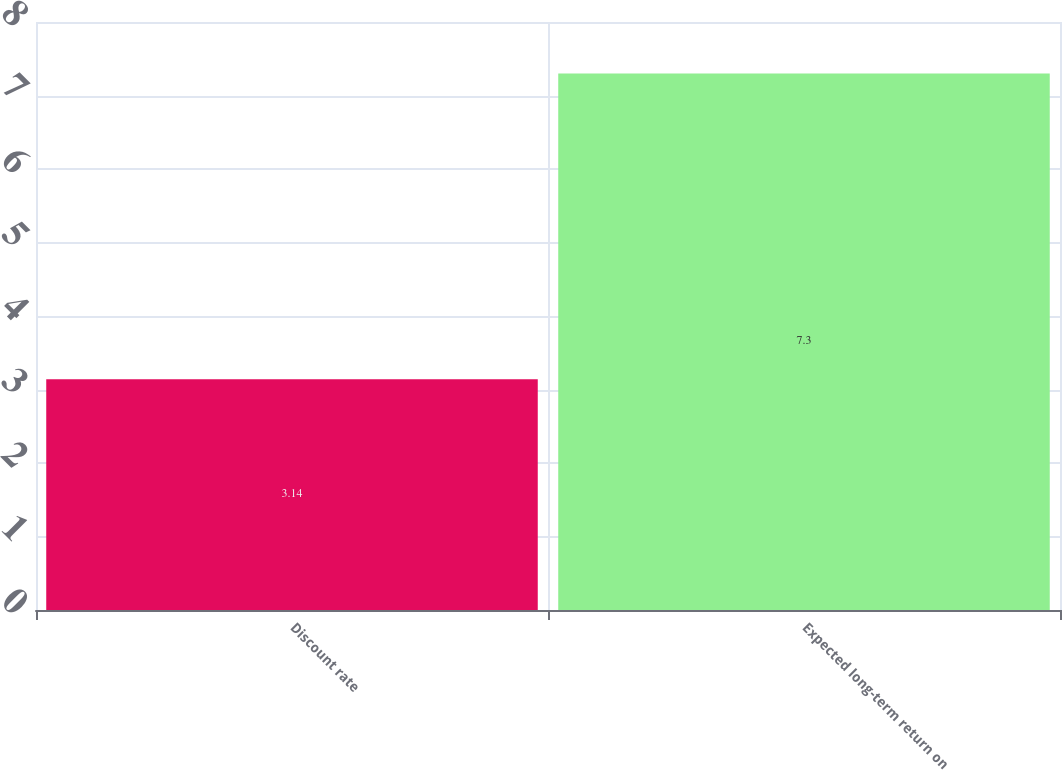<chart> <loc_0><loc_0><loc_500><loc_500><bar_chart><fcel>Discount rate<fcel>Expected long-term return on<nl><fcel>3.14<fcel>7.3<nl></chart> 